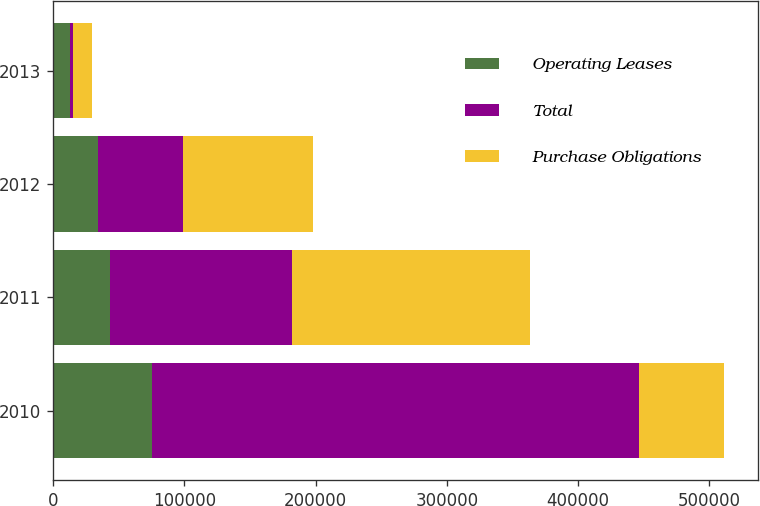<chart> <loc_0><loc_0><loc_500><loc_500><stacked_bar_chart><ecel><fcel>2010<fcel>2011<fcel>2012<fcel>2013<nl><fcel>Operating Leases<fcel>75340<fcel>43073<fcel>34297<fcel>13211<nl><fcel>Total<fcel>371384<fcel>138641<fcel>64555<fcel>1600<nl><fcel>Purchase Obligations<fcel>64555<fcel>181714<fcel>98852<fcel>14811<nl></chart> 